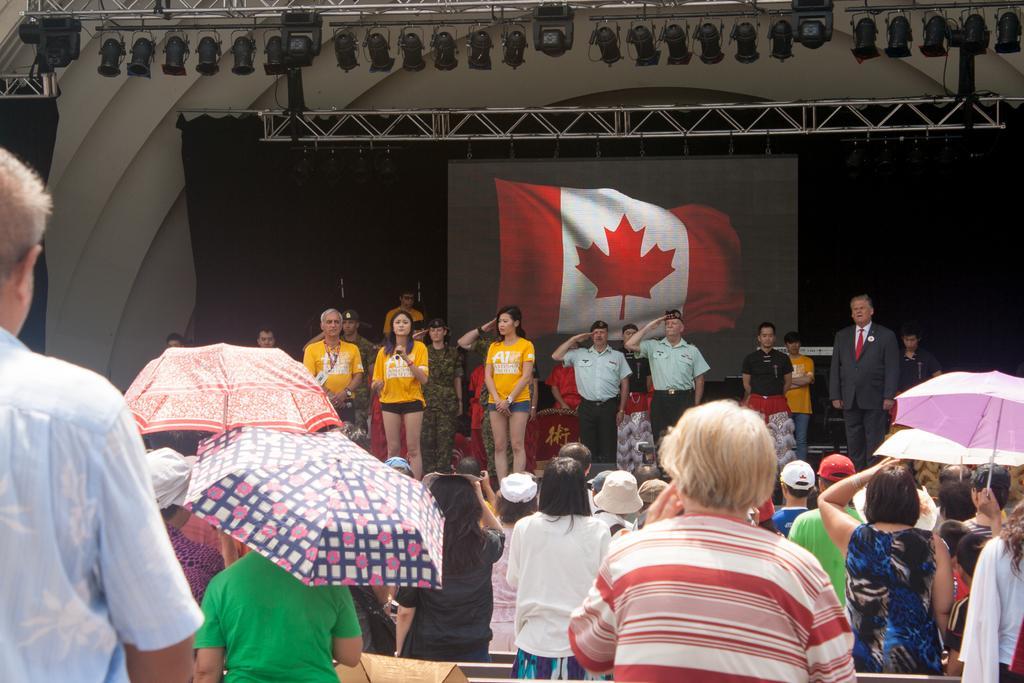In one or two sentences, can you explain what this image depicts? In this image, we can see a group of people, umbrellas. Few people are wearing caps. In the middle of the image, we can see few people are standing. Here a woman is holding some object. Here few people are saluting with their hands. Background there is a screen, curtain. Top of the image, we can see rods and lights. 